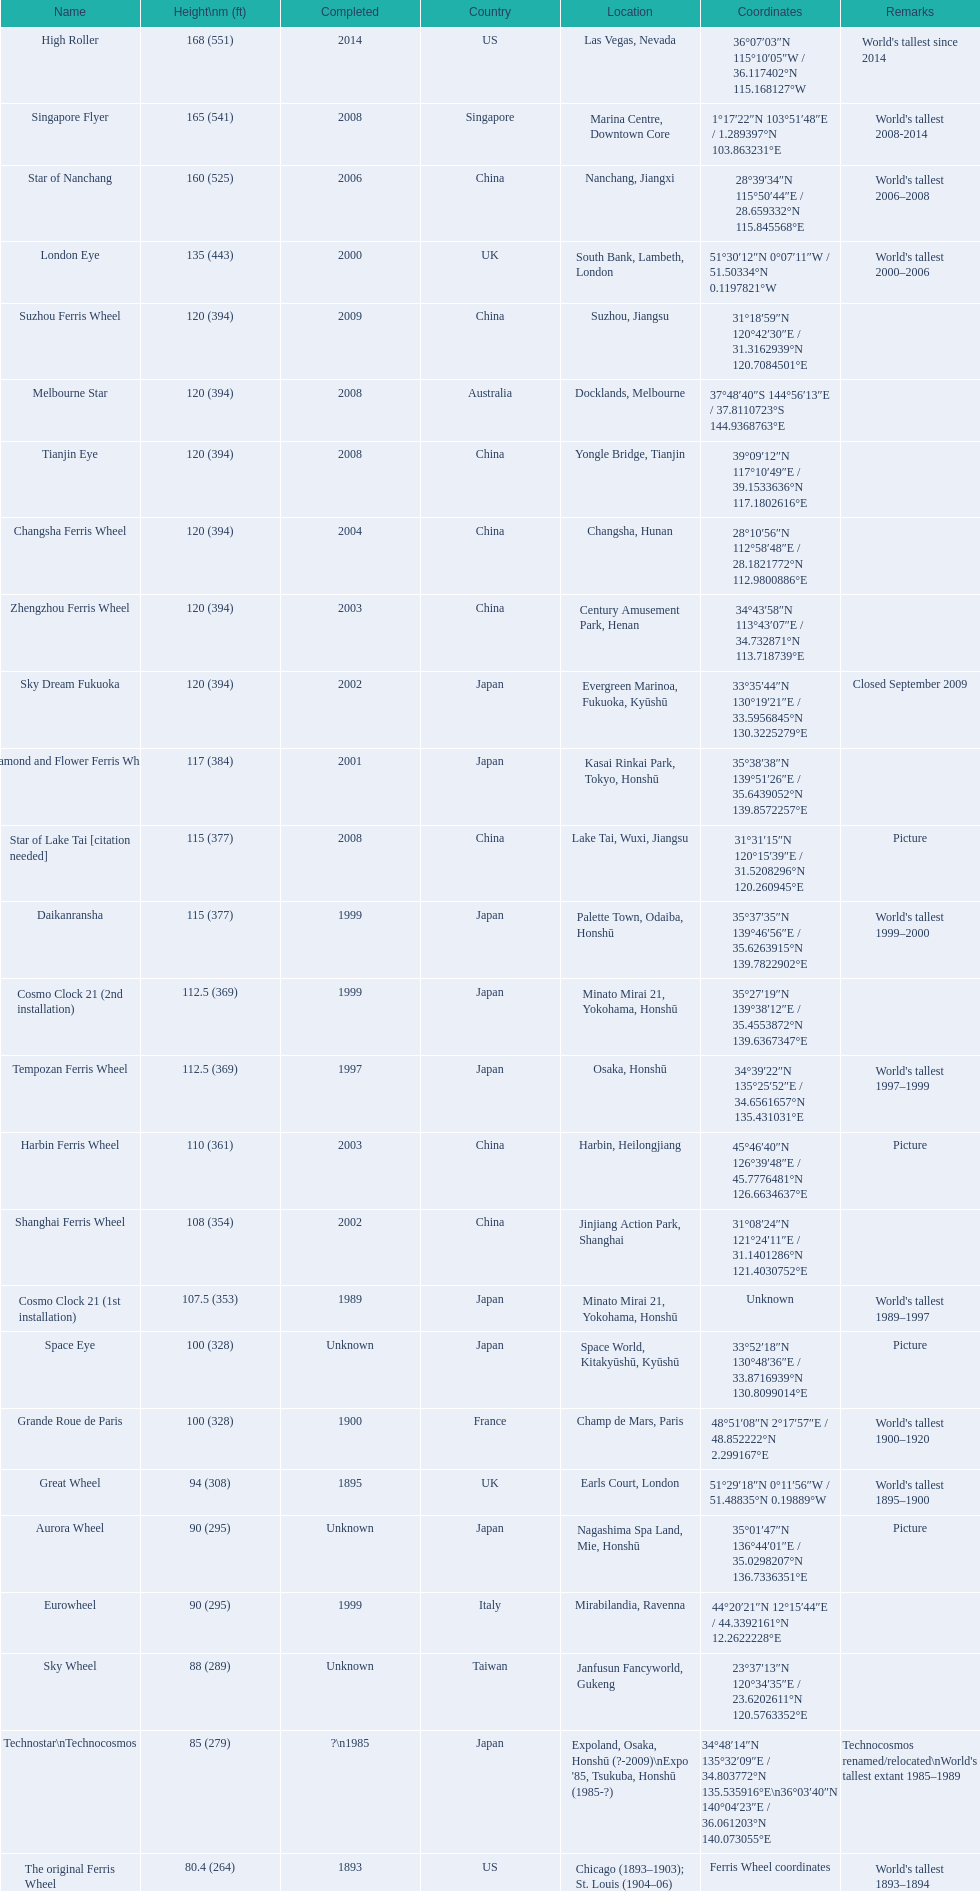What are all of the ferris wheel names? High Roller, Singapore Flyer, Star of Nanchang, London Eye, Suzhou Ferris Wheel, Melbourne Star, Tianjin Eye, Changsha Ferris Wheel, Zhengzhou Ferris Wheel, Sky Dream Fukuoka, Diamond and Flower Ferris Wheel, Star of Lake Tai [citation needed], Daikanransha, Cosmo Clock 21 (2nd installation), Tempozan Ferris Wheel, Harbin Ferris Wheel, Shanghai Ferris Wheel, Cosmo Clock 21 (1st installation), Space Eye, Grande Roue de Paris, Great Wheel, Aurora Wheel, Eurowheel, Sky Wheel, Technostar\nTechnocosmos, The original Ferris Wheel. What was the height of each one? 168 (551), 165 (541), 160 (525), 135 (443), 120 (394), 120 (394), 120 (394), 120 (394), 120 (394), 120 (394), 117 (384), 115 (377), 115 (377), 112.5 (369), 112.5 (369), 110 (361), 108 (354), 107.5 (353), 100 (328), 100 (328), 94 (308), 90 (295), 90 (295), 88 (289), 85 (279), 80.4 (264). And when were they completed? 2014, 2008, 2006, 2000, 2009, 2008, 2008, 2004, 2003, 2002, 2001, 2008, 1999, 1999, 1997, 2003, 2002, 1989, Unknown, 1900, 1895, Unknown, 1999, Unknown, ?\n1985, 1893. Which were completed in 2008? Singapore Flyer, Melbourne Star, Tianjin Eye, Star of Lake Tai [citation needed]. And of those ferris wheels, which had a height of 165 meters? Singapore Flyer. 